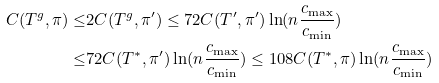Convert formula to latex. <formula><loc_0><loc_0><loc_500><loc_500>C ( T ^ { g } , \pi ) \leq & 2 C ( T ^ { g } , \pi ^ { \prime } ) \leq 7 2 C ( T ^ { \prime } , \pi ^ { \prime } ) \ln ( n \frac { c _ { \max } } { c _ { \min } } ) \\ \leq & 7 2 C ( T ^ { * } , \pi ^ { \prime } ) \ln ( n \frac { c _ { \max } } { c _ { \min } } ) \leq 1 0 8 C ( T ^ { * } , \pi ) \ln ( n \frac { c _ { \max } } { c _ { \min } } )</formula> 